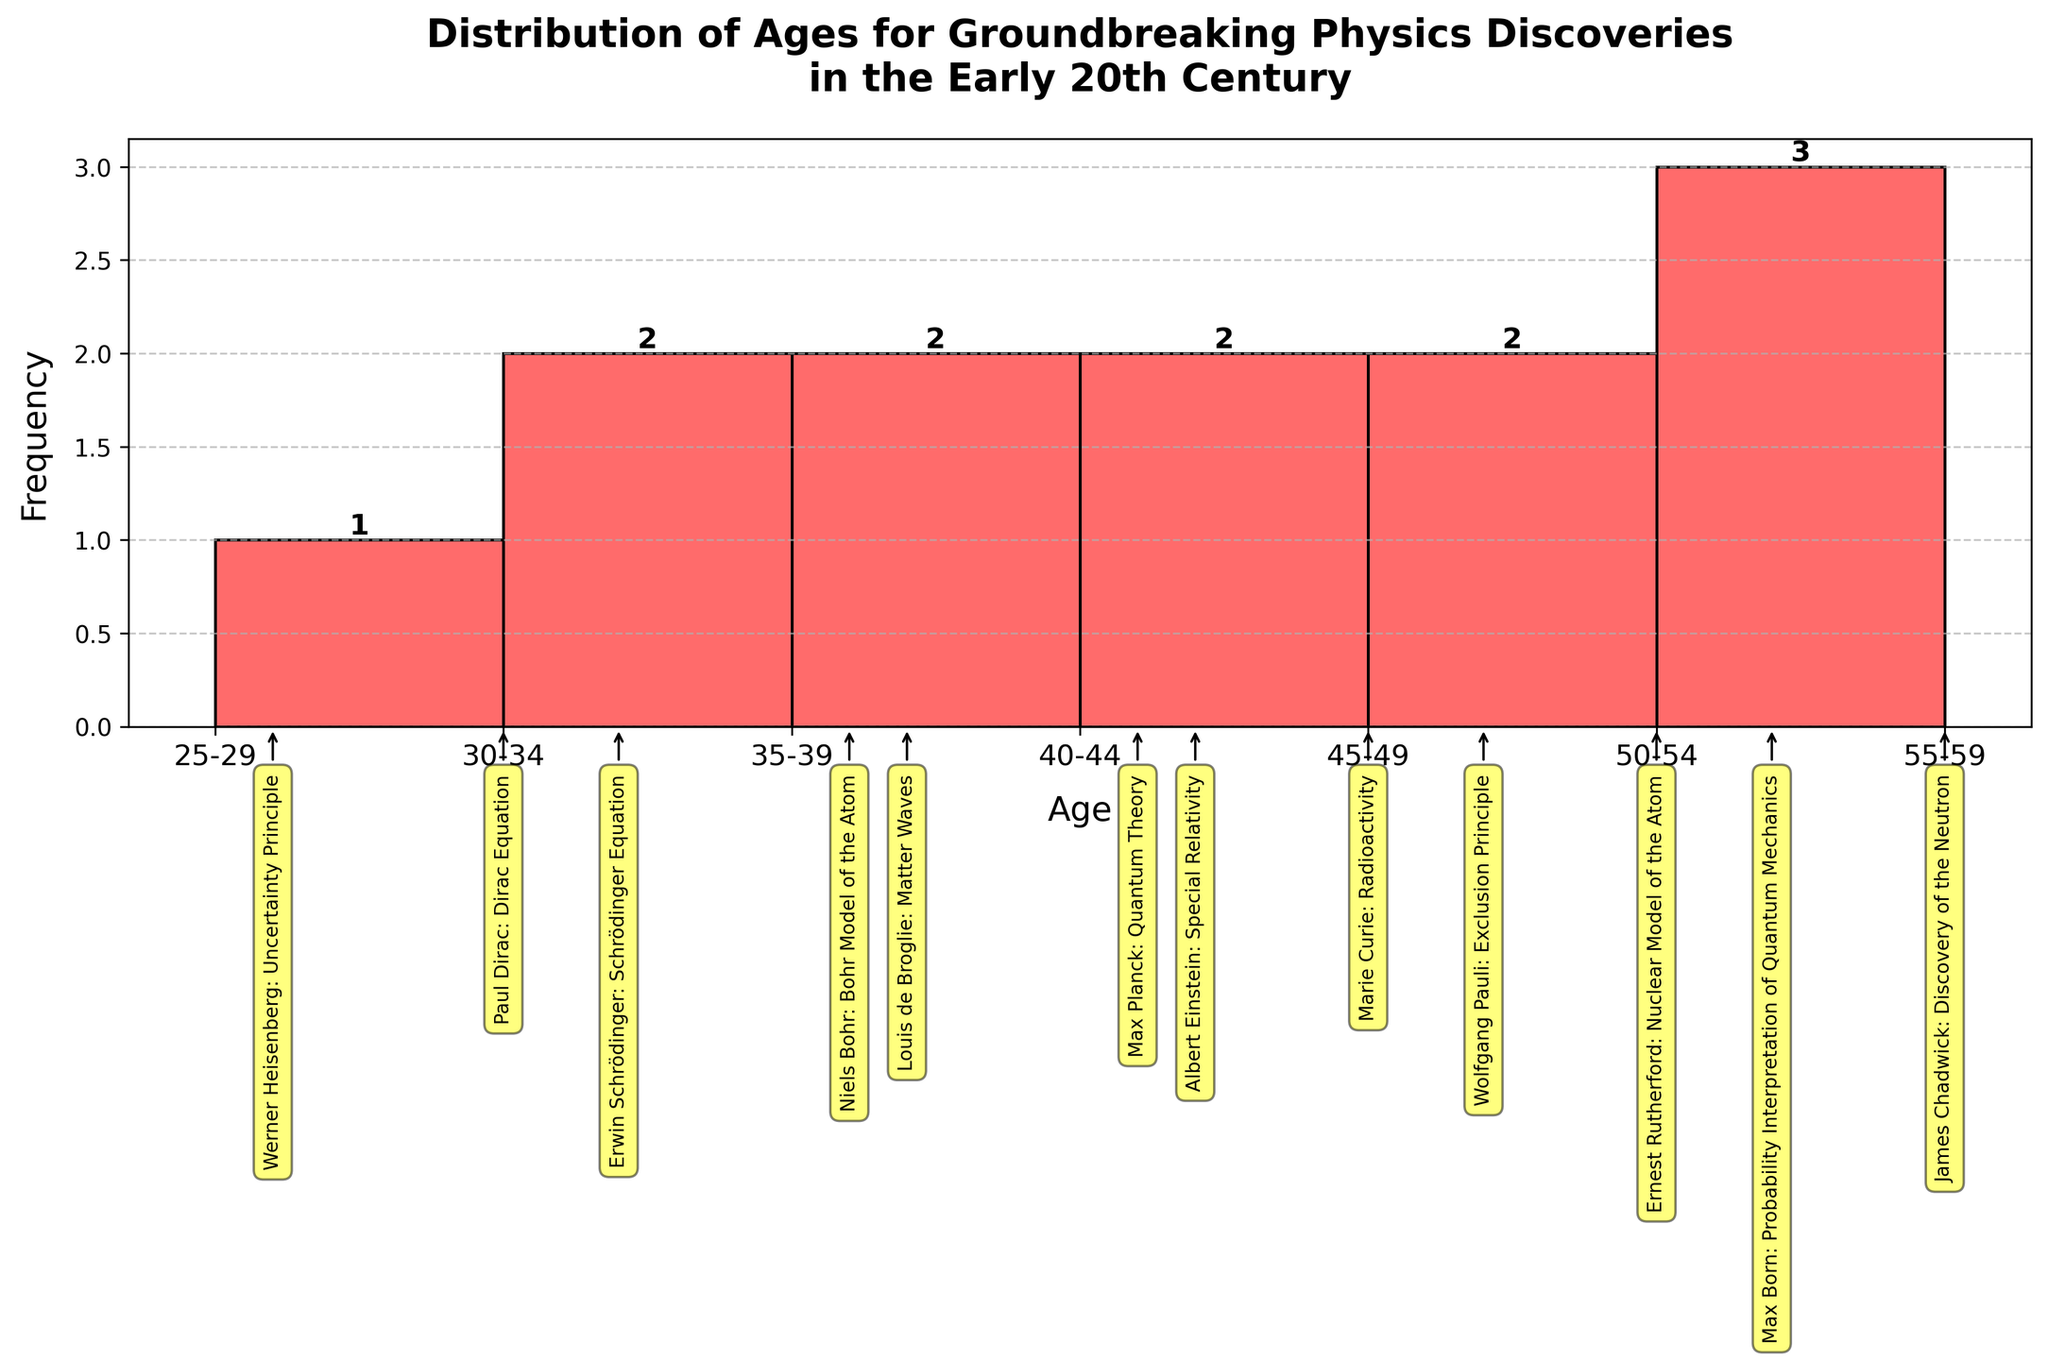what is the title of the figure? The title of the figure is displayed at the top and reads "Distribution of Ages for Groundbreaking Physics Discoveries in the Early 20th Century".
Answer: Distribution of Ages for Groundbreaking Physics Discoveries in the Early 20th Century What are the age ranges shown on the x-axis? The x-axis shows age ranges in increments of 5 years, specifically from 25-29, 30-34, 35-39, 40-44, 45-49, 50-54, and 55-59. These ranges are shown as labels on the x-axis.
Answer: 25-29, 30-34, 35-39, 40-44, 45-49, 50-54, 55-59 How many physicists made their discoveries between the ages of 25 and 29? Look at the height of the bars within the age range 25-29. The bar reaches up to 1, indicating one physicist made a discovery at this age range.
Answer: 1 What's the age range with the highest frequency of discoveries? The tallest bar in the histogram indicates the highest frequency of discoveries. The 30-34 age range has the highest bar, which shows the greatest number of discoveries.
Answer: 30-34 Which physicist made a groundbreaking discovery at the age of 41? There is a vertical annotation aligned with the age of 41 that identifies Max Planck as having made the discovery of Quantum Theory at that age.
Answer: Max Planck What is the total number of physicists referenced in this histogram? Sum up the number of physicists from the height of all the bars in the histogram: 1 (25-29) + 1 (30-34) + 2 (35-39) + 2 (40-44) + 2 (45-49) + 2 (50-54) + 1 (55-59) = 11.
Answer: 11 What is the average age at which physicists made their discoveries according to the histogram? To calculate the average age, multiply each midpoint of the age ranges by the frequency and then sum these products. Then divide by the total number of physicists. (27*1) + (32*1) + (37*2) + (42*2) + (47*2) + (52*2) + (57*1) = 27 + 32 + 74 + 84 + 94 + 104 + 57 = 472. Average is 472/11 ≈ 42.91.
Answer: 42.91 Who made their discovery at the oldest age shown in the histogram? The figure shows an annotation at the highest age of 55, identifying James Chadwick who discovered the Neutron.
Answer: James Chadwick Comparing those aged in their 40s to those in their 50s, which age group had more physicists making discoveries? Sum the frequencies of the 40-44 and 45-49 bars (2+2) and compare it to the sum of the frequencies of the 50-54 and 55-59 bars (2+1). The first group has 4 while the second has 3, indicating more physicists made discoveries in their 40s.
Answer: Physicists in their 40s How many physicists made their discoveries at the age of 50 or older? Sum the frequencies of the bars representing ages 50-54 and 55-59: 2+1=3. This indicates that three physicists made their discoveries at the age of 50 or older.
Answer: 3 